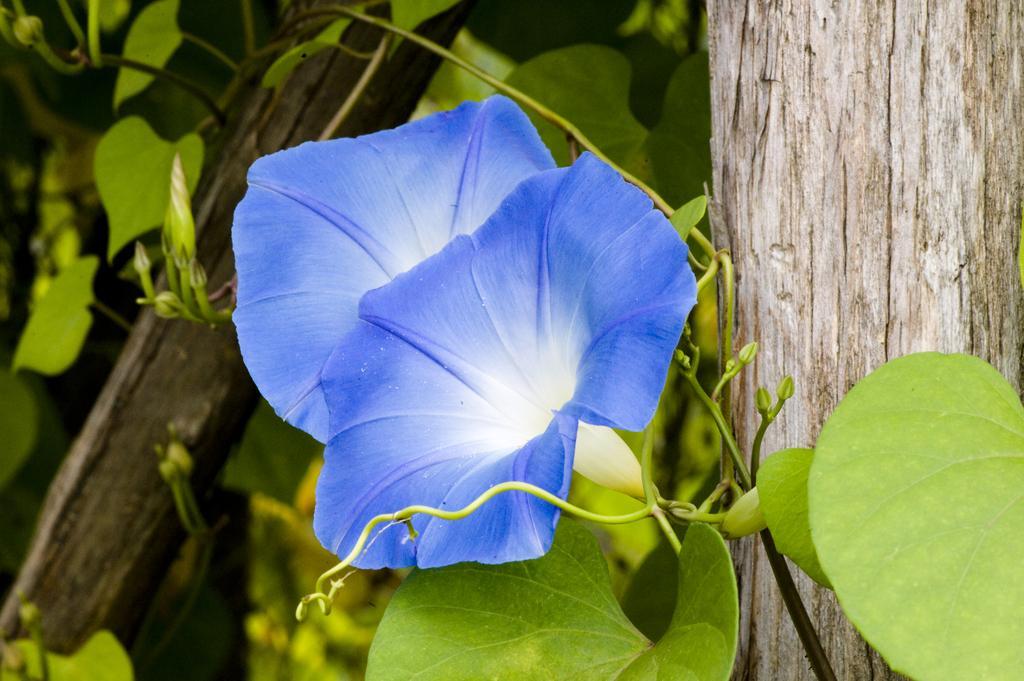Describe this image in one or two sentences. Here in this picture we can see flowers present on a plant and we can also see some wooden planks also present. 